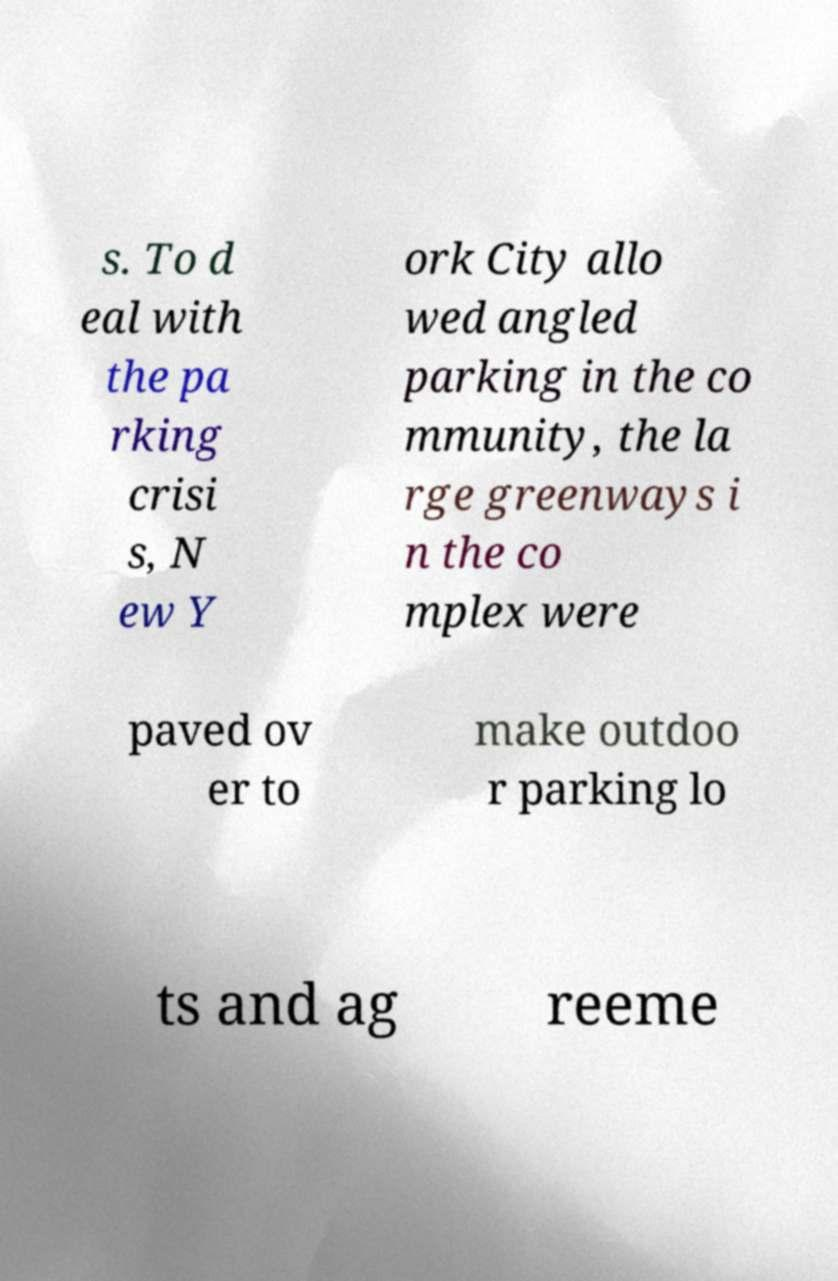Could you assist in decoding the text presented in this image and type it out clearly? s. To d eal with the pa rking crisi s, N ew Y ork City allo wed angled parking in the co mmunity, the la rge greenways i n the co mplex were paved ov er to make outdoo r parking lo ts and ag reeme 